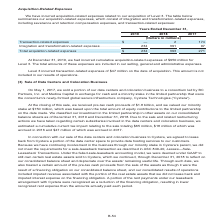According to Centurylink's financial document, What was the amount of cumulative acquisition-related expenses incurred for Level 3 in 2019? According to the financial document, $950 million. The relevant text states: "ncurred cumulative acquisition-related expenses of $950 million for Level 3. The total amounts of these expenses are included in our selling, general and administra..." Also, What was the amount of transaction-related expenses incurred for Level 3 on the date of acquisition? According to the financial document, $47 million. The relevant text states: "Level 3 incurred transaction-related expenses of $47 million on the date of acquisition. This amount is not included in our results of operations...." Also, What expenses are included under the acquisition-related expenses? The document contains multiple relevant values: integration and transformation-related expenses, severance and retention compensation expenses, transaction-related expenses. From the document: "everance and retention compensation expenses, and transaction-related expenses: illions) Transaction-related expenses . $ — 2 174 Integration and tran..." Additionally, Which year incurred the lowest amount of total acquisition-related expenses? According to the financial document, 2019. The relevant text states: "2019 2018 2017..." Also, can you calculate: What is the change in the total acquisition-related expense in 2019 from 2018? Based on the calculation: 234-393, the result is -159 (in millions). This is based on the information: "Total acquisition-related expenses . $ 234 393 271 Integration and transformation-related expenses . 234 391 97..." The key data points involved are: 234, 393. Also, can you calculate: What is the percentage change in the total acquisition-related expense in 2019 from 2018? To answer this question, I need to perform calculations using the financial data. The calculation is: (234-393)/393, which equals -40.46 (percentage). This is based on the information: "Total acquisition-related expenses . $ 234 393 271 Integration and transformation-related expenses . 234 391 97..." The key data points involved are: 234, 393. 